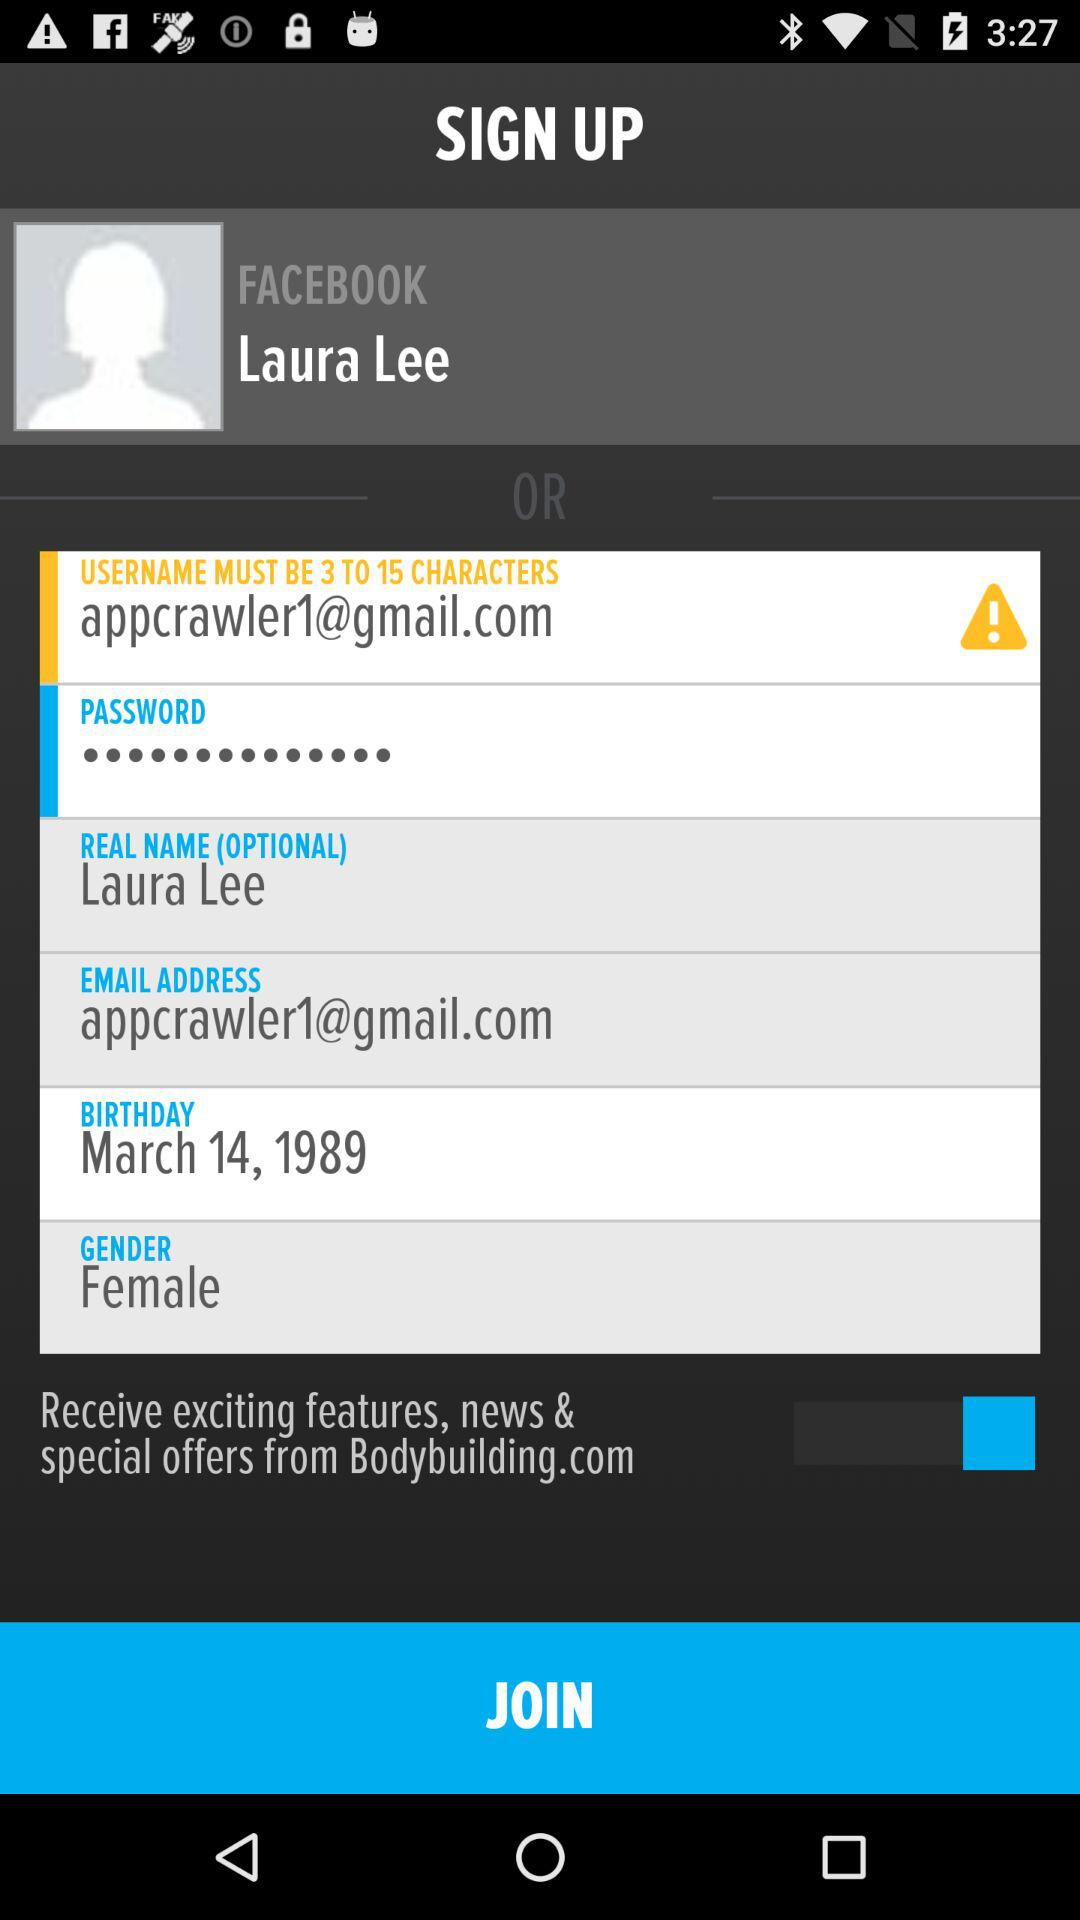What is the status of "Receive exciting features, news & special offers"? The status is "on". 